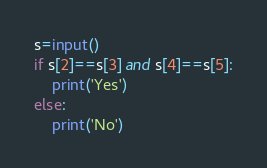<code> <loc_0><loc_0><loc_500><loc_500><_Python_>s=input()
if s[2]==s[3] and s[4]==s[5]:
    print('Yes')
else:
    print('No')
</code> 